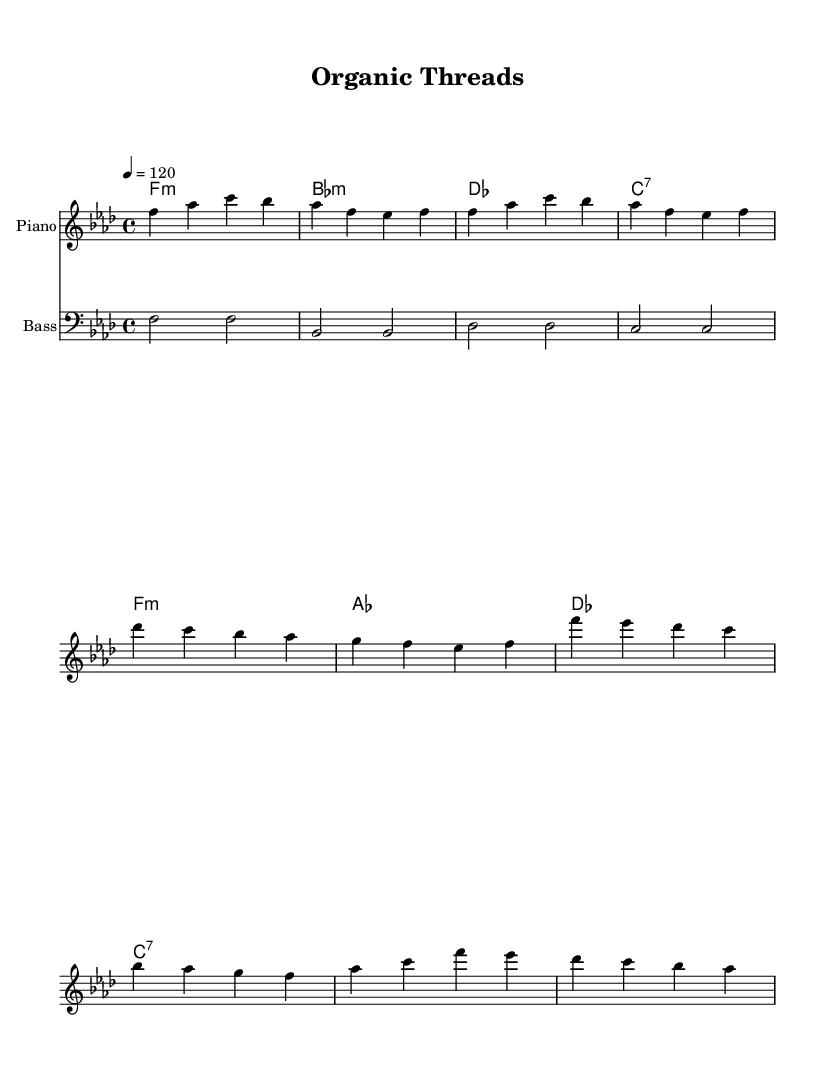What is the key signature of this music? The key signature is indicated by the number of sharps or flats at the beginning of the staff. In this piece, there are four flats, which corresponds to the key of F minor.
Answer: F minor What is the time signature of this music? The time signature is represented by the fraction at the beginning of the sheet music. Here, it shows 4/4, meaning there are four beats per measure, and the quarter note gets one beat.
Answer: 4/4 What is the tempo marking for this piece? The tempo is provided in beats per minute, which in this score is indicated as 4 equals 120, meaning there are 120 beats per minute.
Answer: 120 What is the first note of the melody? The first note of the melody is the starting pitch, which is found at the beginning of the melody staff. The first note is F.
Answer: F What is the chord progression in the chorus? The chord progression can be analyzed by looking at the chord symbols listed for the chorus section. It progresses from F minor to A flat, then to D flat and C dominant seventh.
Answer: F minor, A flat, D flat, C seventh How many bars are in the verse section? To determine the number of bars, we count each group of notes segmented by vertical lines, which separate the measures. The verse has four measures.
Answer: Four What natural fiber is mentioned as part of the lyrics? By reviewing the lyrics, we can see that both cotton and hemp are mentioned as natural fibers that contribute to the narrative of the song.
Answer: Cotton, hemp 